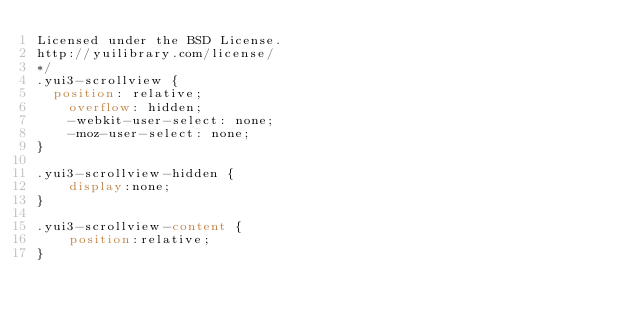Convert code to text. <code><loc_0><loc_0><loc_500><loc_500><_CSS_>Licensed under the BSD License.
http://yuilibrary.com/license/
*/
.yui3-scrollview {
	position: relative;
    overflow: hidden;
    -webkit-user-select: none;
    -moz-user-select: none;
}

.yui3-scrollview-hidden {
    display:none;
}

.yui3-scrollview-content {
    position:relative;
}</code> 